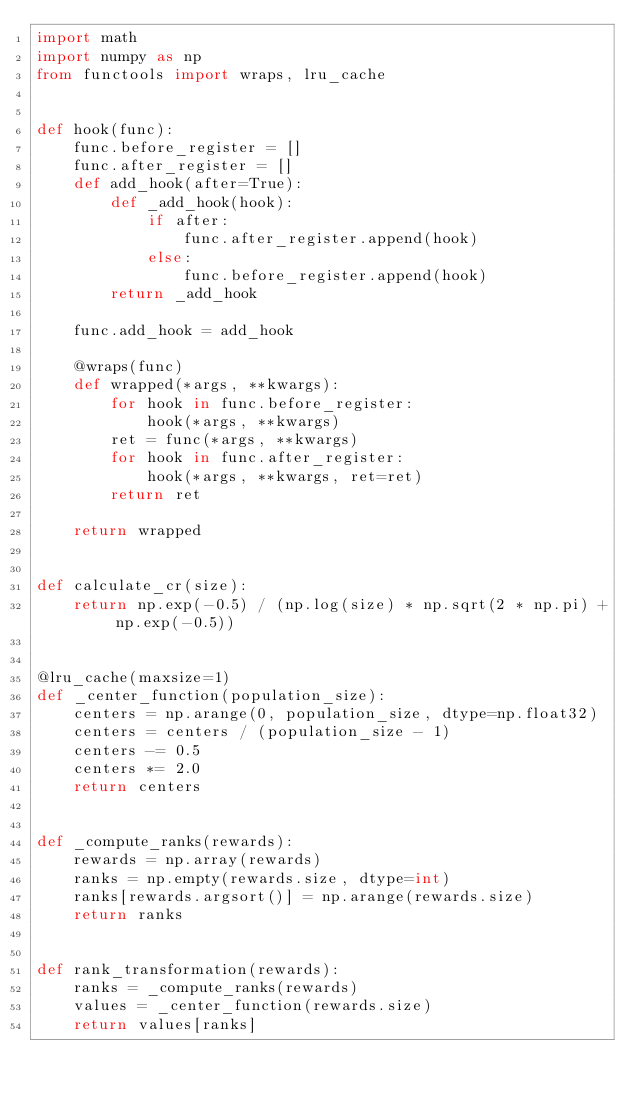<code> <loc_0><loc_0><loc_500><loc_500><_Python_>import math
import numpy as np
from functools import wraps, lru_cache


def hook(func):
    func.before_register = []
    func.after_register = []
    def add_hook(after=True):
        def _add_hook(hook):
            if after:
                func.after_register.append(hook)
            else:
                func.before_register.append(hook)
        return _add_hook

    func.add_hook = add_hook

    @wraps(func)
    def wrapped(*args, **kwargs):
        for hook in func.before_register:
            hook(*args, **kwargs)
        ret = func(*args, **kwargs)
        for hook in func.after_register:
            hook(*args, **kwargs, ret=ret)
        return ret

    return wrapped


def calculate_cr(size):
    return np.exp(-0.5) / (np.log(size) * np.sqrt(2 * np.pi) + np.exp(-0.5))


@lru_cache(maxsize=1)
def _center_function(population_size):
    centers = np.arange(0, population_size, dtype=np.float32)
    centers = centers / (population_size - 1)
    centers -= 0.5
    centers *= 2.0
    return centers


def _compute_ranks(rewards):
    rewards = np.array(rewards)
    ranks = np.empty(rewards.size, dtype=int)
    ranks[rewards.argsort()] = np.arange(rewards.size)
    return ranks


def rank_transformation(rewards):
    ranks = _compute_ranks(rewards)
    values = _center_function(rewards.size)
    return values[ranks]
</code> 